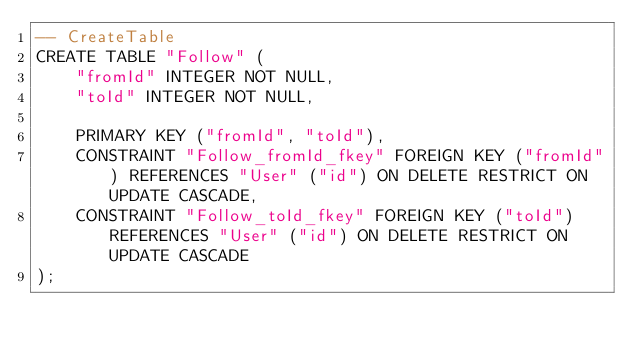Convert code to text. <code><loc_0><loc_0><loc_500><loc_500><_SQL_>-- CreateTable
CREATE TABLE "Follow" (
    "fromId" INTEGER NOT NULL,
    "toId" INTEGER NOT NULL,

    PRIMARY KEY ("fromId", "toId"),
    CONSTRAINT "Follow_fromId_fkey" FOREIGN KEY ("fromId") REFERENCES "User" ("id") ON DELETE RESTRICT ON UPDATE CASCADE,
    CONSTRAINT "Follow_toId_fkey" FOREIGN KEY ("toId") REFERENCES "User" ("id") ON DELETE RESTRICT ON UPDATE CASCADE
);
</code> 